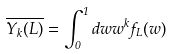<formula> <loc_0><loc_0><loc_500><loc_500>\overline { Y _ { k } ( L ) } = \int _ { 0 } ^ { 1 } d w w ^ { k } f _ { L } ( w )</formula> 